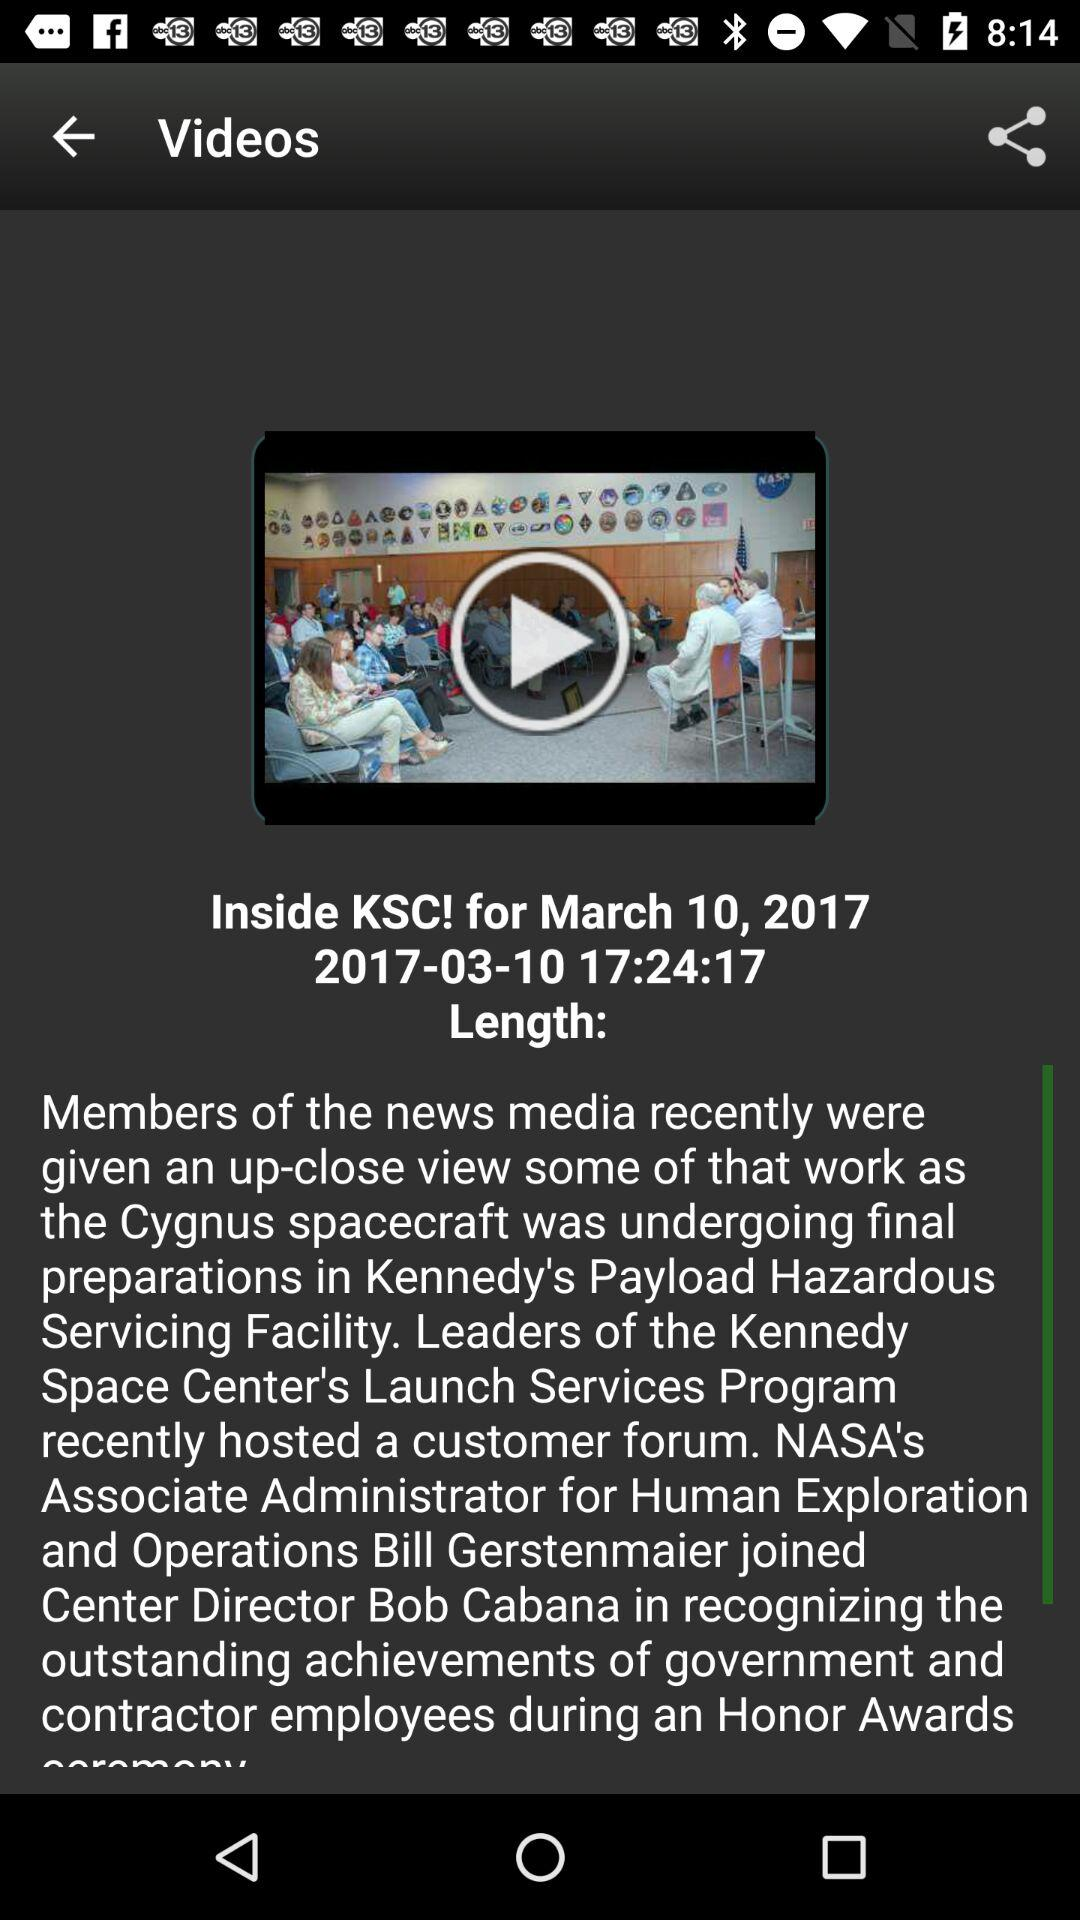How long is the video?
When the provided information is insufficient, respond with <no answer>. <no answer> 